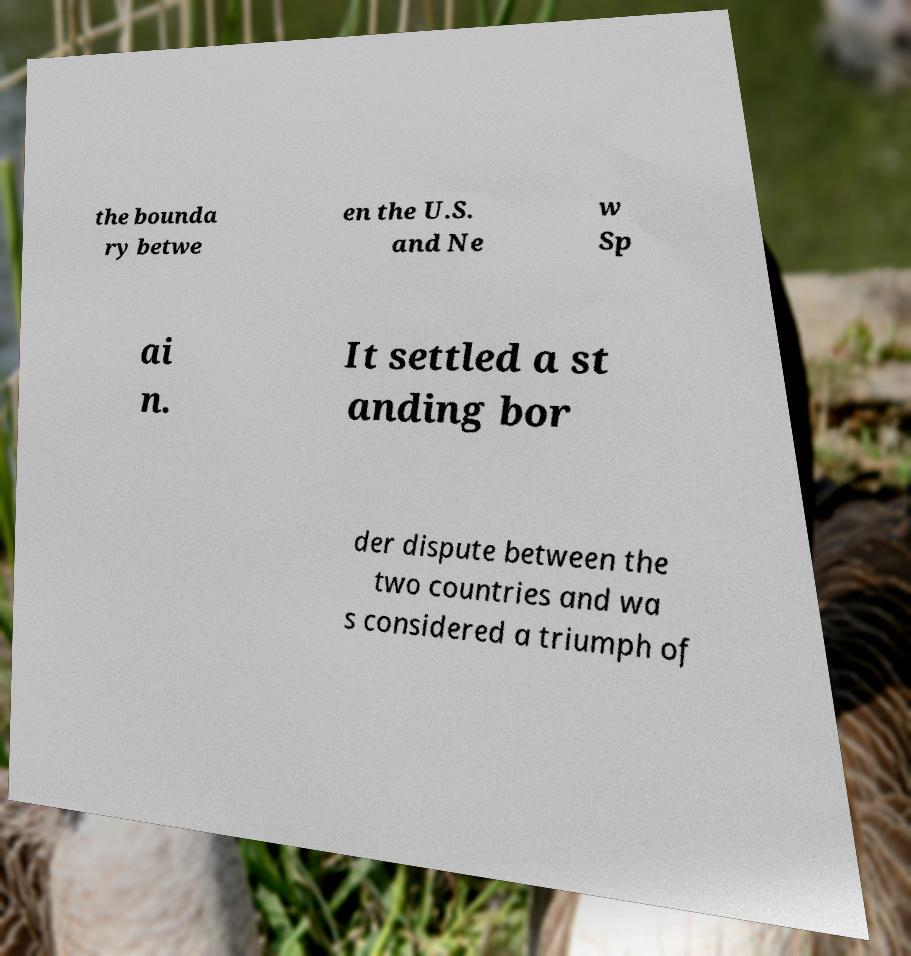I need the written content from this picture converted into text. Can you do that? the bounda ry betwe en the U.S. and Ne w Sp ai n. It settled a st anding bor der dispute between the two countries and wa s considered a triumph of 